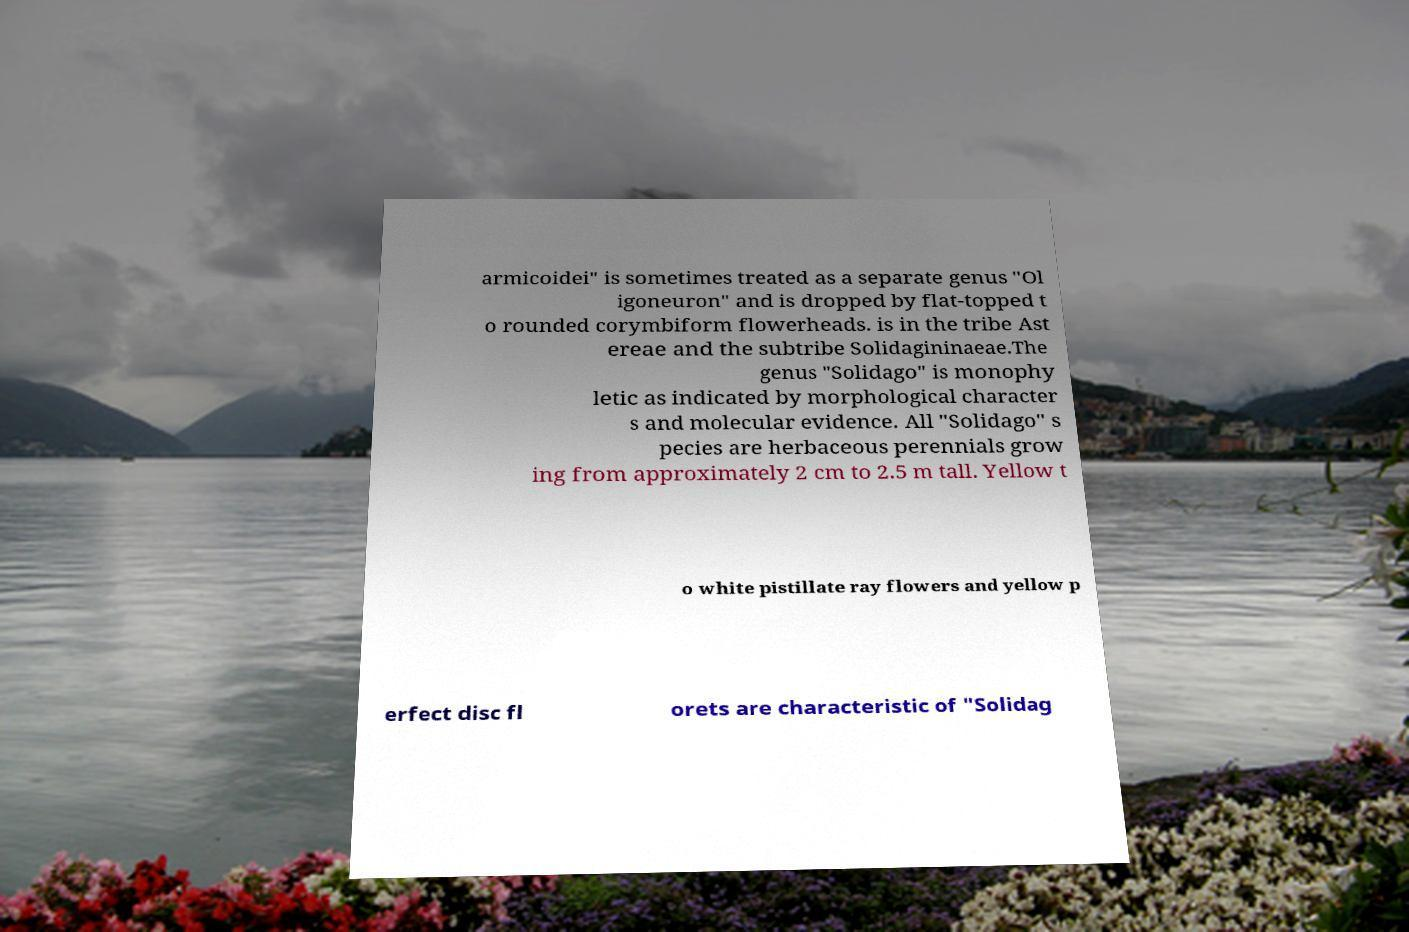I need the written content from this picture converted into text. Can you do that? armicoidei" is sometimes treated as a separate genus "Ol igoneuron" and is dropped by flat-topped t o rounded corymbiform flowerheads. is in the tribe Ast ereae and the subtribe Solidagininaeae.The genus "Solidago" is monophy letic as indicated by morphological character s and molecular evidence. All "Solidago" s pecies are herbaceous perennials grow ing from approximately 2 cm to 2.5 m tall. Yellow t o white pistillate ray flowers and yellow p erfect disc fl orets are characteristic of "Solidag 